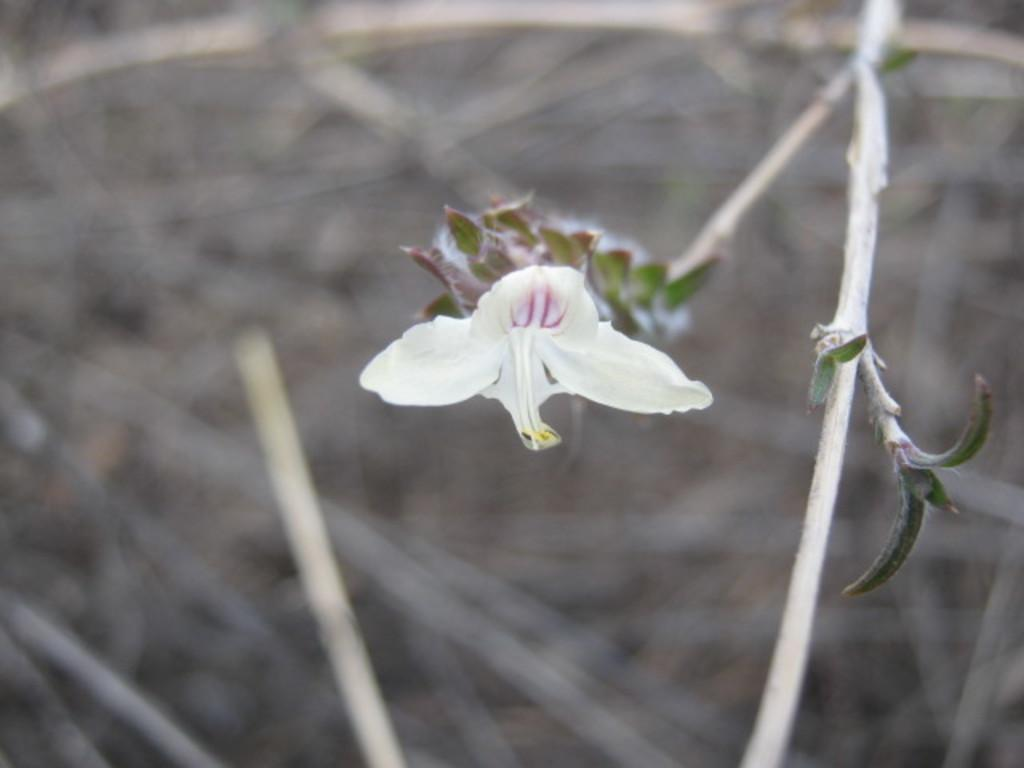What is the main subject of the image? There is a flower in the center of the image. What else can be seen in the image besides the flower? Leaves are present in the image. What part of the flower is visible in the image? The stems of the flower are visible. How would you describe the background of the image? The background of the image is blurred. Can you see a giraffe in the image? No, there is no giraffe present in the image. Is there a person thinking about the flower in the image? There is no person depicted in the image, and therefore no thoughts about the flower can be observed. 